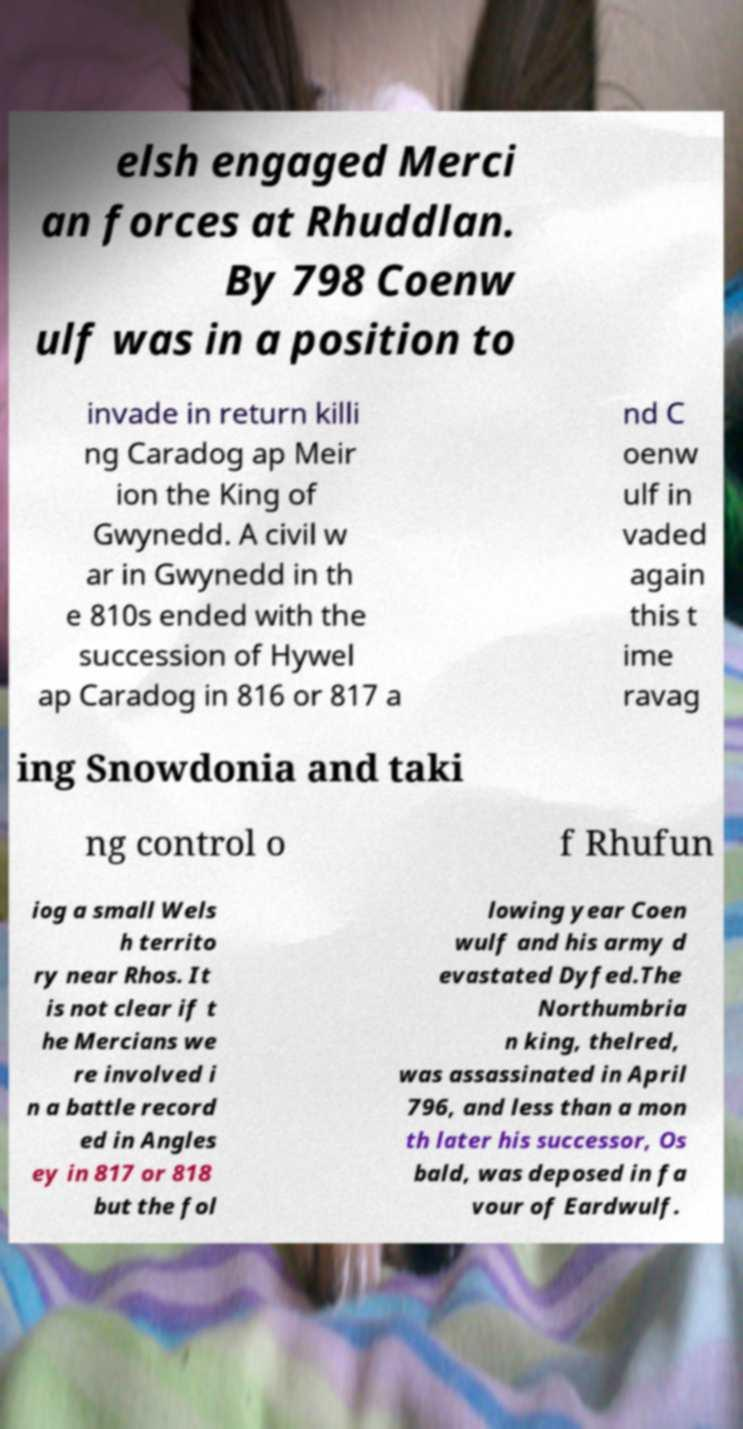Can you read and provide the text displayed in the image?This photo seems to have some interesting text. Can you extract and type it out for me? elsh engaged Merci an forces at Rhuddlan. By 798 Coenw ulf was in a position to invade in return killi ng Caradog ap Meir ion the King of Gwynedd. A civil w ar in Gwynedd in th e 810s ended with the succession of Hywel ap Caradog in 816 or 817 a nd C oenw ulf in vaded again this t ime ravag ing Snowdonia and taki ng control o f Rhufun iog a small Wels h territo ry near Rhos. It is not clear if t he Mercians we re involved i n a battle record ed in Angles ey in 817 or 818 but the fol lowing year Coen wulf and his army d evastated Dyfed.The Northumbria n king, thelred, was assassinated in April 796, and less than a mon th later his successor, Os bald, was deposed in fa vour of Eardwulf. 